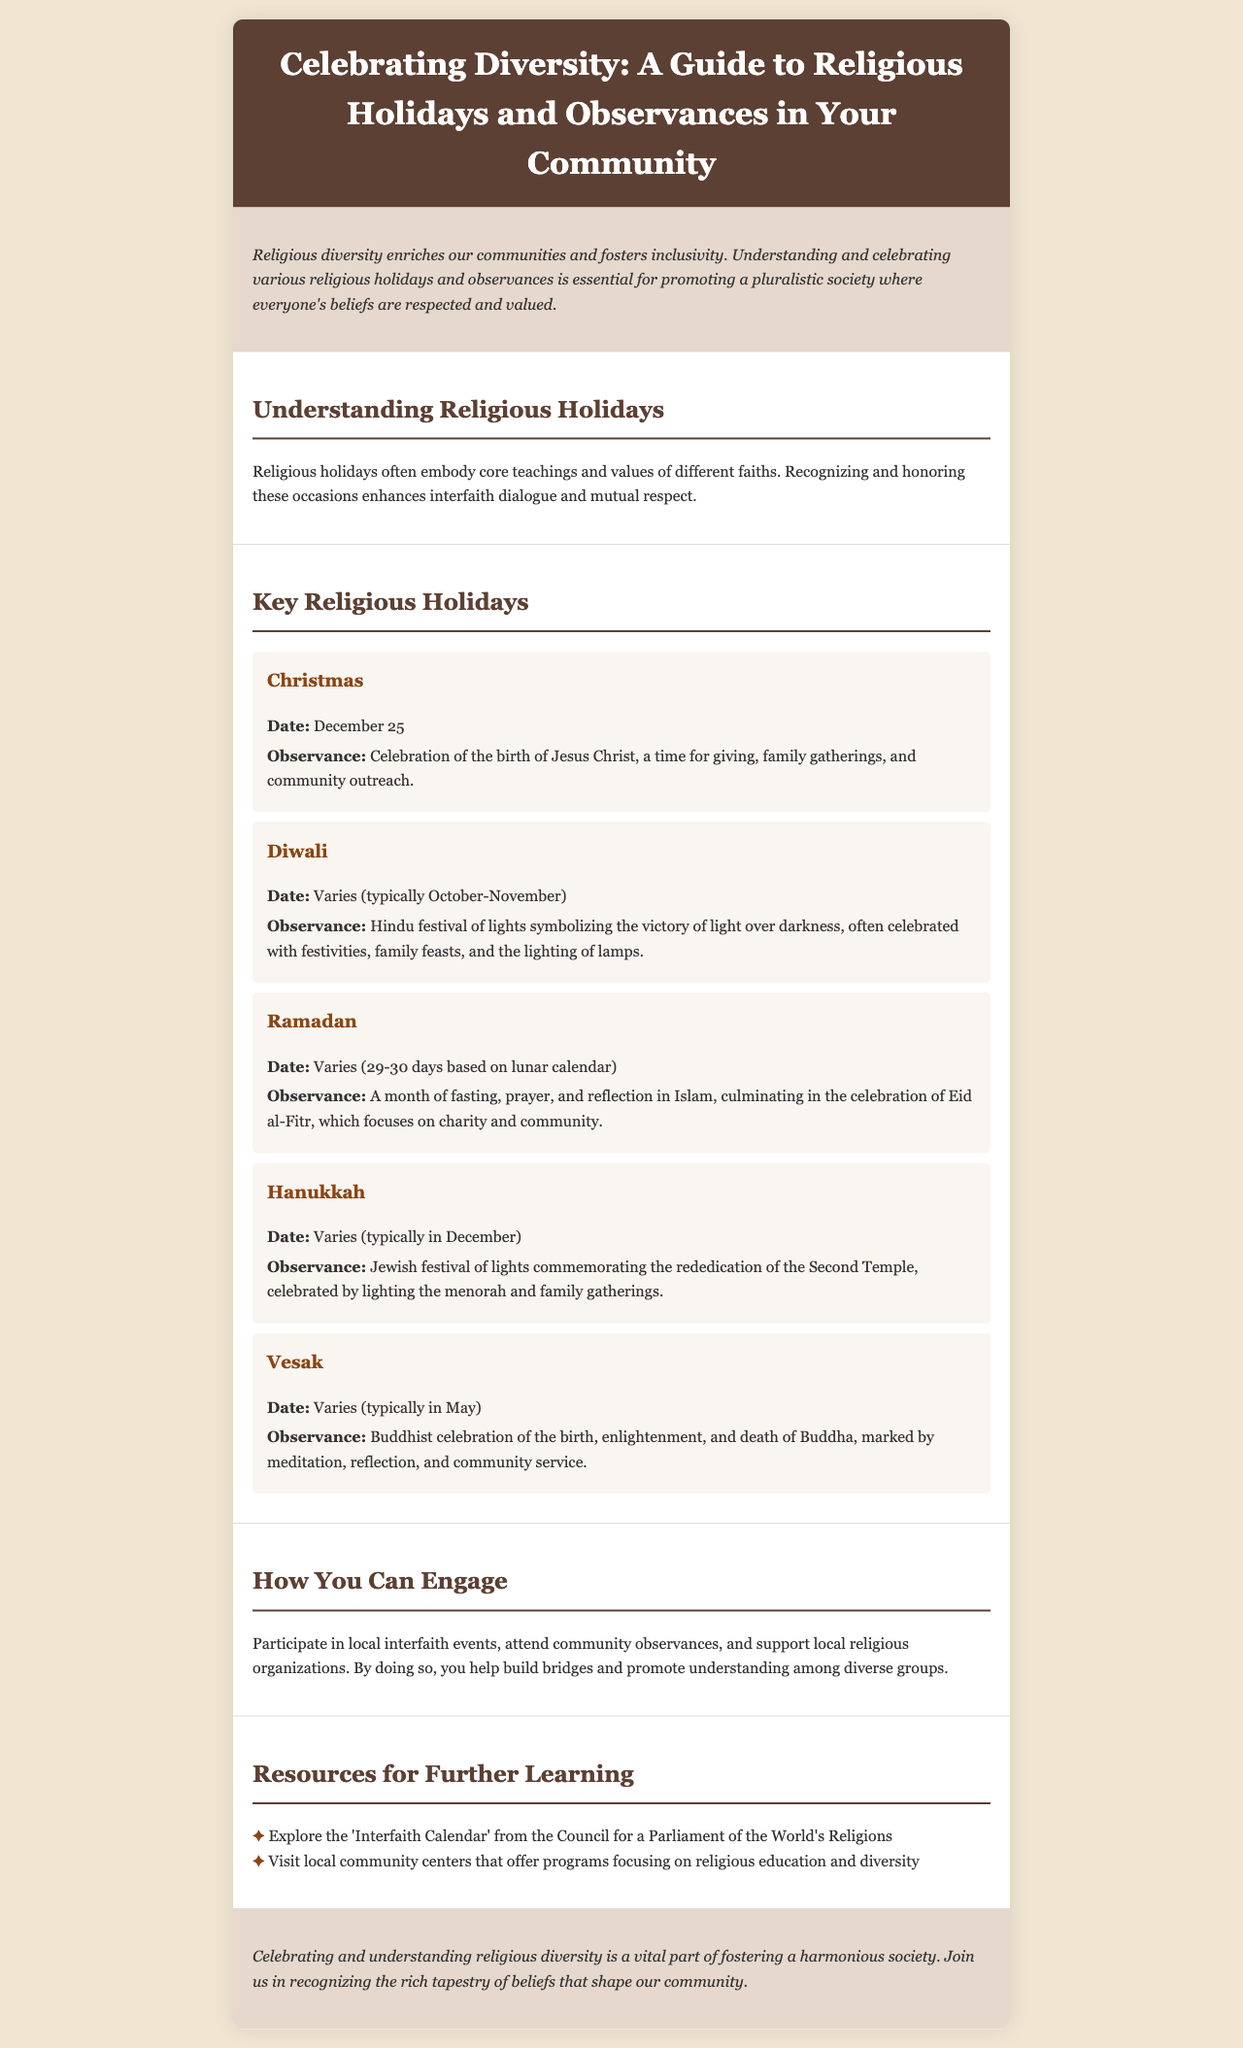what is the title of the brochure? The title is explicitly stated in the header section of the document.
Answer: Celebrating Diversity: A Guide to Religious Holidays and Observances in Your Community when is Christmas celebrated? The document specifies the date for Christmas in the holiday section.
Answer: December 25 what is the observance associated with Diwali? The document provides details about the observance of Diwali in the key religious holidays section.
Answer: Hindu festival of lights symbolizing the victory of light over darkness how long does Ramadan last? The document notes that Ramadan is based on the lunar calendar and provides a range for its duration.
Answer: 29-30 days what activity can you engage in to support religious diversity? The brochure mentions a specific way to engage in the community regarding religious observances.
Answer: Participate in local interfaith events what is a resource mentioned for further learning? One of the listed resources in the document highlights a particular educational resource.
Answer: Interfaith Calendar from the Council for a Parliament of the World's Religions what is the main purpose of the brochure? The document outlines its purpose in the introduction section.
Answer: Promoting a pluralistic society where everyone's beliefs are respected and valued what festival celebrates the birth, enlightenment, and death of Buddha? The document directly refers to a specific religious celebration and its significance.
Answer: Vesak 